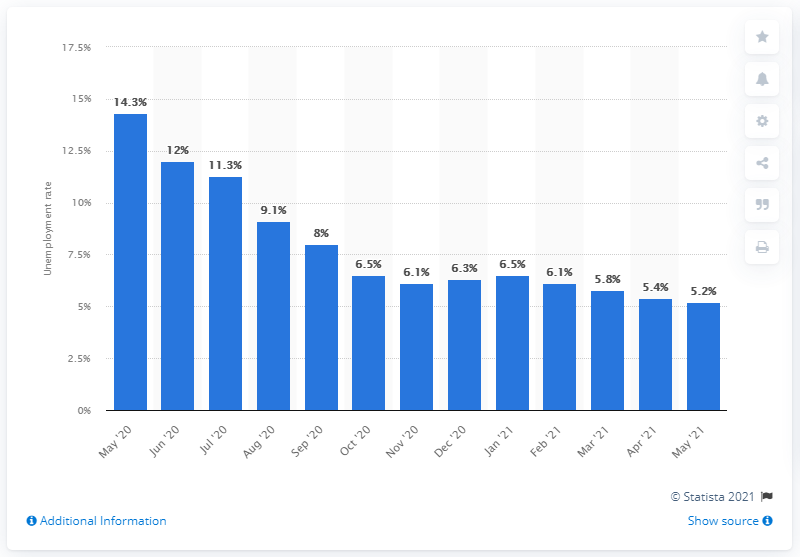Give some essential details in this illustration. In May 2021, the unadjusted unemployment rate for women was 5.2%. In May of 2021, the unadjusted unemployment rate for women was 5.4%. 